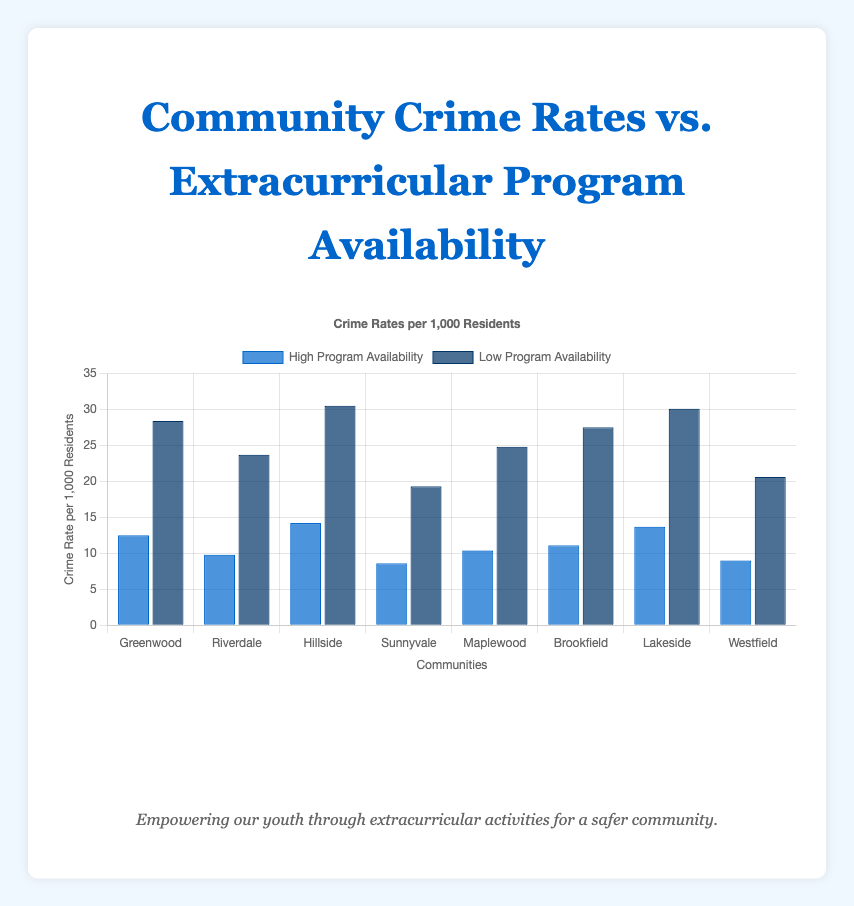Which community has the highest crime rate with high program availability? Looking at the bar for each community, Greenwood has the highest crime rate with high program availability at 14.2 per 1,000 residents.
Answer: Greenwood What is the difference in crime rates between high and low program availability in Hillside? The crime rate in Hillside with high program availability is 14.2, and with low program availability, it is 30.5. The difference is 30.5 - 14.2 = 16.3.
Answer: 16.3 Which community shows the lowest crime rate with low program availability? Sunnyvale has the lowest crime rate with low program availability at 19.3 per 1,000 residents.
Answer: Sunnyvale How does the crime rate in Riverdale with low program availability compare to that in Brookfield with high program availability? The crime rate in Riverdale with low program availability is 23.7, and in Brookfield with high program availability, it is 11.1. The crime rate in Riverdale with low program availability is higher than in Brookfield with high program availability.
Answer: Riverdale > Brookfield By how much does the crime rate decrease in Lakeside when comparing low to high program availability? The crime rate in Lakeside with low program availability is 30.1, and with high program availability, it is 13.7. The decrease is 30.1 - 13.7 = 16.4.
Answer: 16.4 What is the average crime rate of all communities with high program availability? The crime rates with high program availability are 12.5, 9.8, 14.2, 8.6, 10.4, 11.1, 13.7, and 9.0. Summing these rates yields 89.3, and the average is 89.3 / 8 = 11.16.
Answer: 11.16 Which communities have a higher crime rate with low program availability compared to the crime rate with high program availability in Maplewood? Maplewood has a crime rate of 10.4 with high program availability. Communities with a low program availability crime rate higher than 10.4 are Greenwood (28.4), Riverdale (23.7), Hillside (30.5), Sunnyvale (19.3), Brookfield (27.5), Lakeside (30.1), and Westfield (20.6).
Answer: Greenwood, Riverdale, Hillside, Sunnyvale, Brookfield, Lakeside, Westfield 